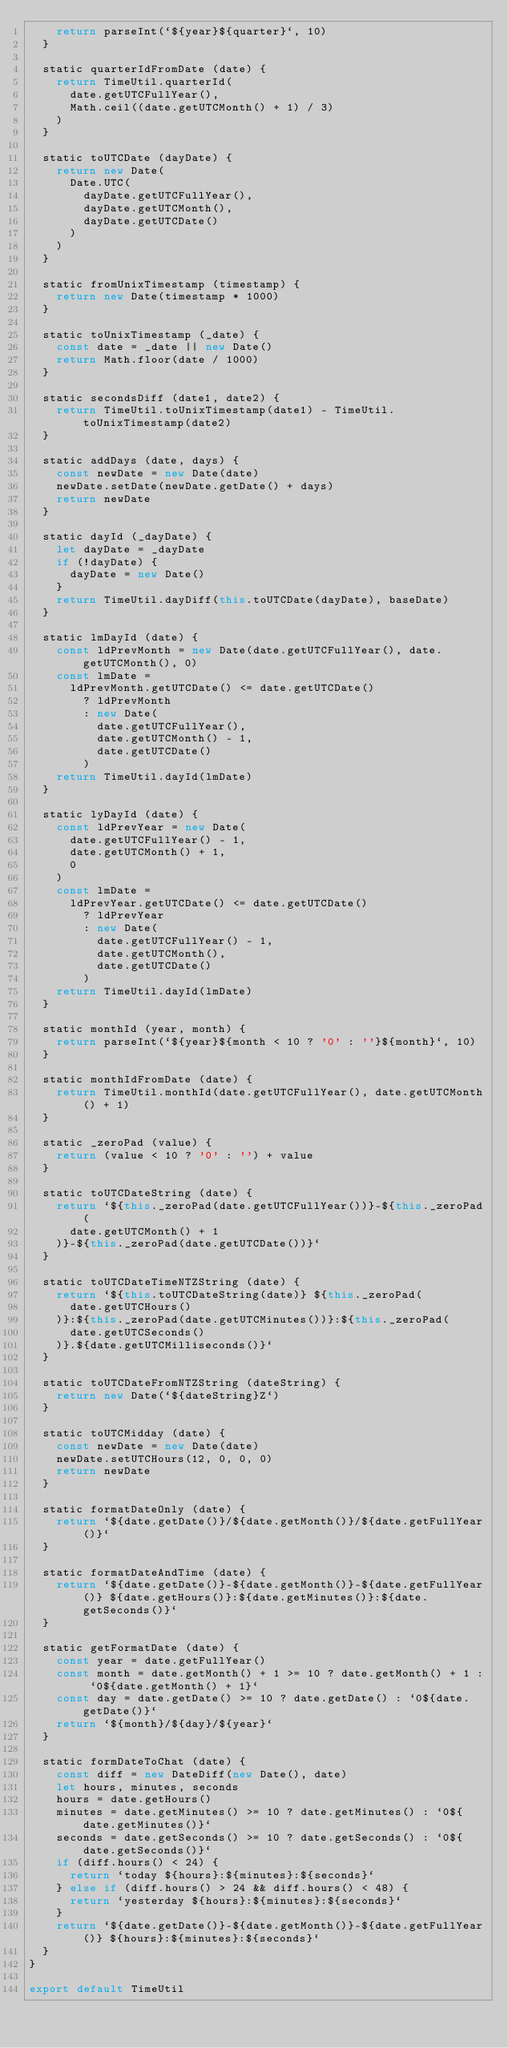Convert code to text. <code><loc_0><loc_0><loc_500><loc_500><_JavaScript_>    return parseInt(`${year}${quarter}`, 10)
  }

  static quarterIdFromDate (date) {
    return TimeUtil.quarterId(
      date.getUTCFullYear(),
      Math.ceil((date.getUTCMonth() + 1) / 3)
    )
  }

  static toUTCDate (dayDate) {
    return new Date(
      Date.UTC(
        dayDate.getUTCFullYear(),
        dayDate.getUTCMonth(),
        dayDate.getUTCDate()
      )
    )
  }

  static fromUnixTimestamp (timestamp) {
    return new Date(timestamp * 1000)
  }

  static toUnixTimestamp (_date) {
    const date = _date || new Date()
    return Math.floor(date / 1000)
  }

  static secondsDiff (date1, date2) {
    return TimeUtil.toUnixTimestamp(date1) - TimeUtil.toUnixTimestamp(date2)
  }

  static addDays (date, days) {
    const newDate = new Date(date)
    newDate.setDate(newDate.getDate() + days)
    return newDate
  }

  static dayId (_dayDate) {
    let dayDate = _dayDate
    if (!dayDate) {
      dayDate = new Date()
    }
    return TimeUtil.dayDiff(this.toUTCDate(dayDate), baseDate)
  }

  static lmDayId (date) {
    const ldPrevMonth = new Date(date.getUTCFullYear(), date.getUTCMonth(), 0)
    const lmDate =
      ldPrevMonth.getUTCDate() <= date.getUTCDate()
        ? ldPrevMonth
        : new Date(
          date.getUTCFullYear(),
          date.getUTCMonth() - 1,
          date.getUTCDate()
        )
    return TimeUtil.dayId(lmDate)
  }

  static lyDayId (date) {
    const ldPrevYear = new Date(
      date.getUTCFullYear() - 1,
      date.getUTCMonth() + 1,
      0
    )
    const lmDate =
      ldPrevYear.getUTCDate() <= date.getUTCDate()
        ? ldPrevYear
        : new Date(
          date.getUTCFullYear() - 1,
          date.getUTCMonth(),
          date.getUTCDate()
        )
    return TimeUtil.dayId(lmDate)
  }

  static monthId (year, month) {
    return parseInt(`${year}${month < 10 ? '0' : ''}${month}`, 10)
  }

  static monthIdFromDate (date) {
    return TimeUtil.monthId(date.getUTCFullYear(), date.getUTCMonth() + 1)
  }

  static _zeroPad (value) {
    return (value < 10 ? '0' : '') + value
  }

  static toUTCDateString (date) {
    return `${this._zeroPad(date.getUTCFullYear())}-${this._zeroPad(
      date.getUTCMonth() + 1
    )}-${this._zeroPad(date.getUTCDate())}`
  }

  static toUTCDateTimeNTZString (date) {
    return `${this.toUTCDateString(date)} ${this._zeroPad(
      date.getUTCHours()
    )}:${this._zeroPad(date.getUTCMinutes())}:${this._zeroPad(
      date.getUTCSeconds()
    )}.${date.getUTCMilliseconds()}`
  }

  static toUTCDateFromNTZString (dateString) {
    return new Date(`${dateString}Z`)
  }

  static toUTCMidday (date) {
    const newDate = new Date(date)
    newDate.setUTCHours(12, 0, 0, 0)
    return newDate
  }

  static formatDateOnly (date) {
    return `${date.getDate()}/${date.getMonth()}/${date.getFullYear()}`
  }

  static formatDateAndTime (date) {
    return `${date.getDate()}-${date.getMonth()}-${date.getFullYear()} ${date.getHours()}:${date.getMinutes()}:${date.getSeconds()}`
  }

  static getFormatDate (date) {
    const year = date.getFullYear()
    const month = date.getMonth() + 1 >= 10 ? date.getMonth() + 1 : `0${date.getMonth() + 1}`
    const day = date.getDate() >= 10 ? date.getDate() : `0${date.getDate()}`
    return `${month}/${day}/${year}`
  }

  static formDateToChat (date) {
    const diff = new DateDiff(new Date(), date)
    let hours, minutes, seconds
    hours = date.getHours()
    minutes = date.getMinutes() >= 10 ? date.getMinutes() : `0${date.getMinutes()}`
    seconds = date.getSeconds() >= 10 ? date.getSeconds() : `0${date.getSeconds()}`
    if (diff.hours() < 24) {
      return `today ${hours}:${minutes}:${seconds}`
    } else if (diff.hours() > 24 && diff.hours() < 48) {
      return `yesterday ${hours}:${minutes}:${seconds}`
    }
    return `${date.getDate()}-${date.getMonth()}-${date.getFullYear()} ${hours}:${minutes}:${seconds}`
  }
}

export default TimeUtil
</code> 